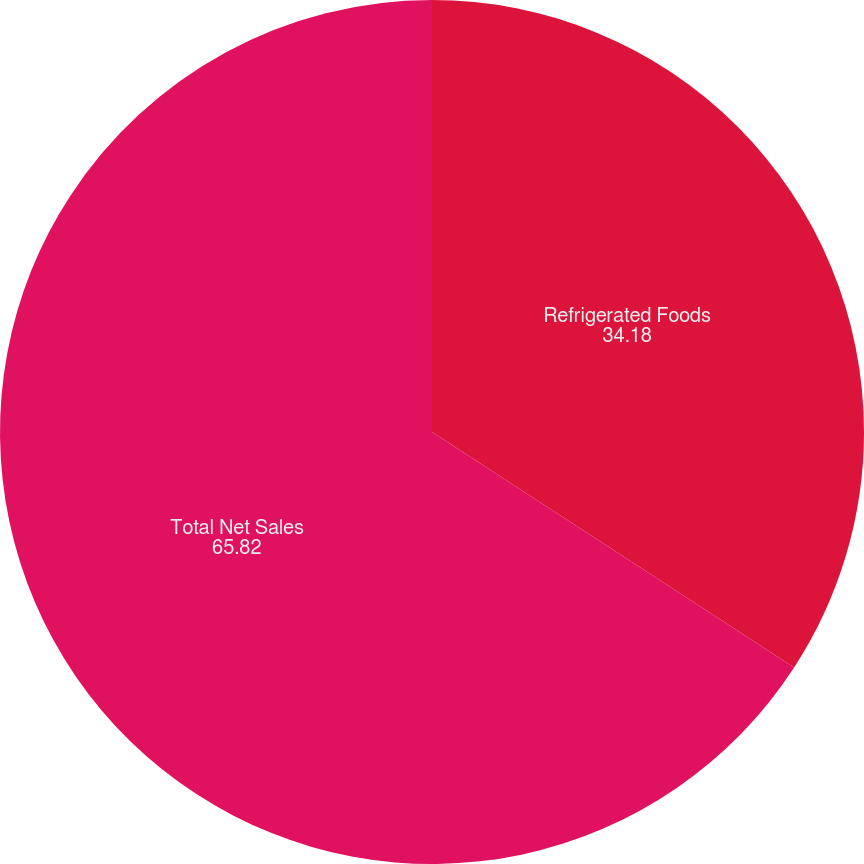<chart> <loc_0><loc_0><loc_500><loc_500><pie_chart><fcel>Refrigerated Foods<fcel>Total Net Sales<nl><fcel>34.18%<fcel>65.82%<nl></chart> 